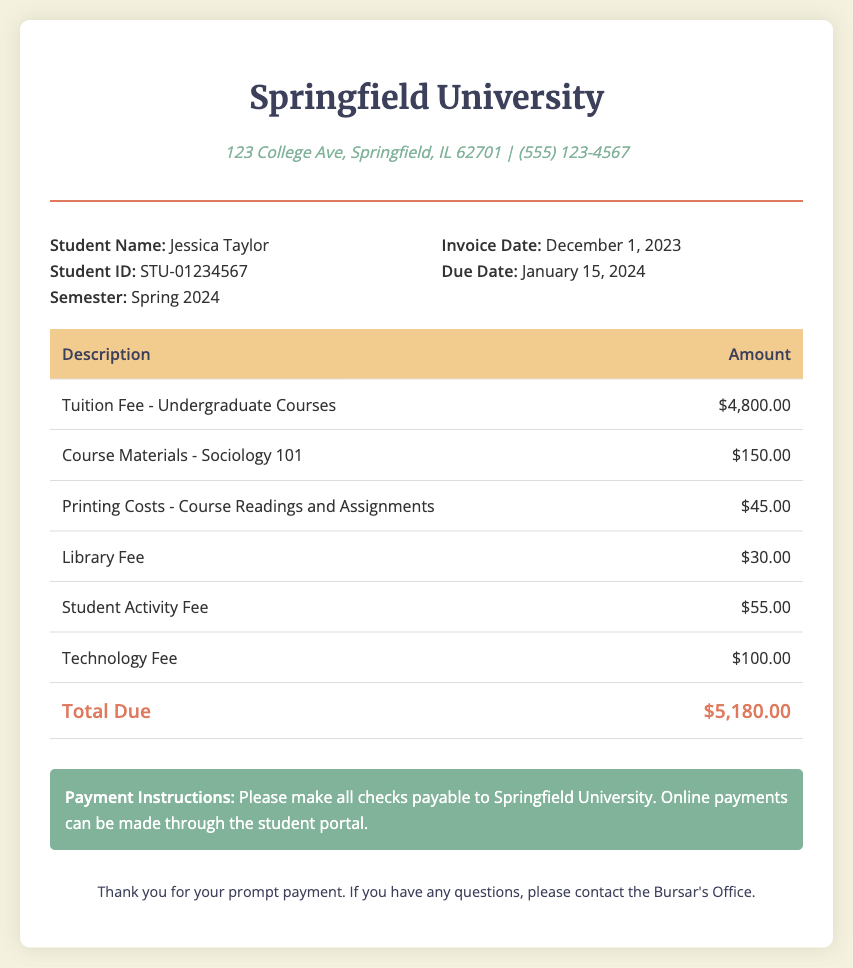What is the total tuition fee for the semester? The total tuition fee is listed as $4,800.00 in the document.
Answer: $4,800.00 Who is the student listed on the invoice? The document states that the student name is Jessica Taylor.
Answer: Jessica Taylor What is the due date for the invoice? The due date mentioned in the document is January 15, 2024.
Answer: January 15, 2024 How much is the printing cost for course readings? The document specifies that the printing costs are $45.00.
Answer: $45.00 What is the total amount due on the invoice? The total amount due is the sum of all the itemized fees listed in the document, which is $5,180.00.
Answer: $5,180.00 What type of invoice is this document? The document is a tuition invoice.
Answer: Tuition invoice What university is issuing this invoice? The name of the university mentioned in the document is Springfield University.
Answer: Springfield University Who can be contacted if there are questions regarding the invoice? The document advises contacting the Bursar's Office for any questions.
Answer: Bursar's Office What is included in the course materials fee? The specific item listed for the course materials is Sociology 101.
Answer: Sociology 101 